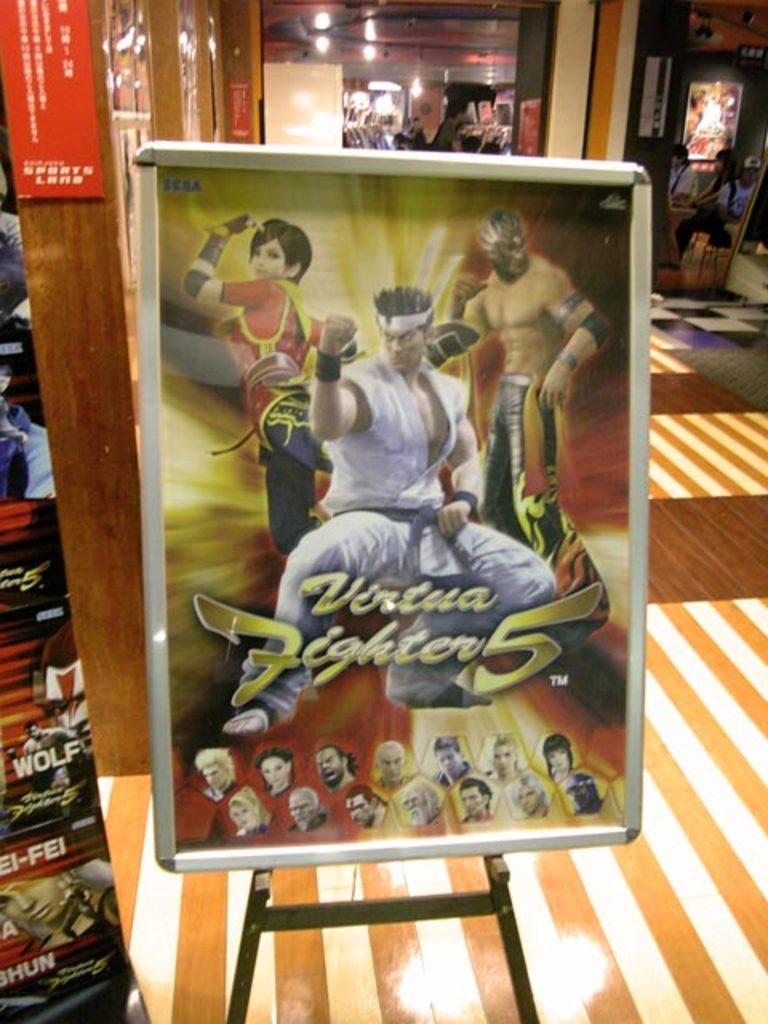What number is this?
Offer a very short reply. 5. 